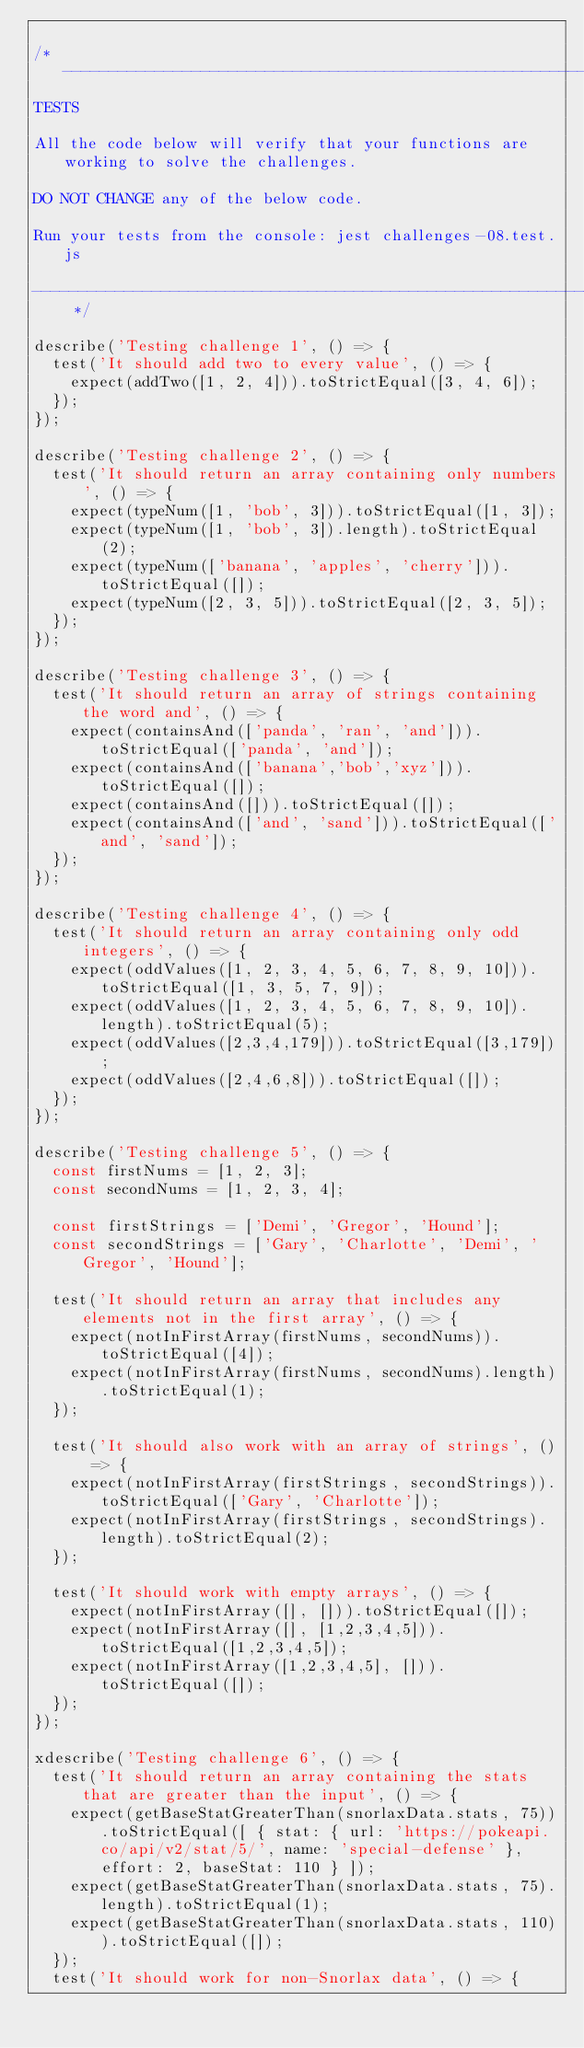Convert code to text. <code><loc_0><loc_0><loc_500><loc_500><_JavaScript_>
/* ------------------------------------------------------------------------------------------------
TESTS

All the code below will verify that your functions are working to solve the challenges.

DO NOT CHANGE any of the below code.

Run your tests from the console: jest challenges-08.test.js

------------------------------------------------------------------------------------------------ */

describe('Testing challenge 1', () => {
  test('It should add two to every value', () => {
    expect(addTwo([1, 2, 4])).toStrictEqual([3, 4, 6]);
  });
});

describe('Testing challenge 2', () => {
  test('It should return an array containing only numbers', () => {
    expect(typeNum([1, 'bob', 3])).toStrictEqual([1, 3]);
    expect(typeNum([1, 'bob', 3]).length).toStrictEqual(2);
    expect(typeNum(['banana', 'apples', 'cherry'])).toStrictEqual([]);
    expect(typeNum([2, 3, 5])).toStrictEqual([2, 3, 5]);
  });
});

describe('Testing challenge 3', () => {
  test('It should return an array of strings containing the word and', () => {
    expect(containsAnd(['panda', 'ran', 'and'])).toStrictEqual(['panda', 'and']);
    expect(containsAnd(['banana','bob','xyz'])).toStrictEqual([]);
    expect(containsAnd([])).toStrictEqual([]);
    expect(containsAnd(['and', 'sand'])).toStrictEqual(['and', 'sand']);
  });
});

describe('Testing challenge 4', () => {
  test('It should return an array containing only odd integers', () => {
    expect(oddValues([1, 2, 3, 4, 5, 6, 7, 8, 9, 10])).toStrictEqual([1, 3, 5, 7, 9]);
    expect(oddValues([1, 2, 3, 4, 5, 6, 7, 8, 9, 10]).length).toStrictEqual(5);
    expect(oddValues([2,3,4,179])).toStrictEqual([3,179]);
    expect(oddValues([2,4,6,8])).toStrictEqual([]);
  });
});

describe('Testing challenge 5', () => {
  const firstNums = [1, 2, 3];
  const secondNums = [1, 2, 3, 4];

  const firstStrings = ['Demi', 'Gregor', 'Hound'];
  const secondStrings = ['Gary', 'Charlotte', 'Demi', 'Gregor', 'Hound'];

  test('It should return an array that includes any elements not in the first array', () => {
    expect(notInFirstArray(firstNums, secondNums)).toStrictEqual([4]);
    expect(notInFirstArray(firstNums, secondNums).length).toStrictEqual(1);
  });

  test('It should also work with an array of strings', () => {
    expect(notInFirstArray(firstStrings, secondStrings)).toStrictEqual(['Gary', 'Charlotte']);
    expect(notInFirstArray(firstStrings, secondStrings).length).toStrictEqual(2);
  });

  test('It should work with empty arrays', () => {
    expect(notInFirstArray([], [])).toStrictEqual([]);
    expect(notInFirstArray([], [1,2,3,4,5])).toStrictEqual([1,2,3,4,5]);
    expect(notInFirstArray([1,2,3,4,5], [])).toStrictEqual([]);
  });
});

xdescribe('Testing challenge 6', () => {
  test('It should return an array containing the stats that are greater than the input', () => {
    expect(getBaseStatGreaterThan(snorlaxData.stats, 75)).toStrictEqual([ { stat: { url: 'https://pokeapi.co/api/v2/stat/5/', name: 'special-defense' }, effort: 2, baseStat: 110 } ]);
    expect(getBaseStatGreaterThan(snorlaxData.stats, 75).length).toStrictEqual(1);
    expect(getBaseStatGreaterThan(snorlaxData.stats, 110)).toStrictEqual([]);
  });
  test('It should work for non-Snorlax data', () => {</code> 